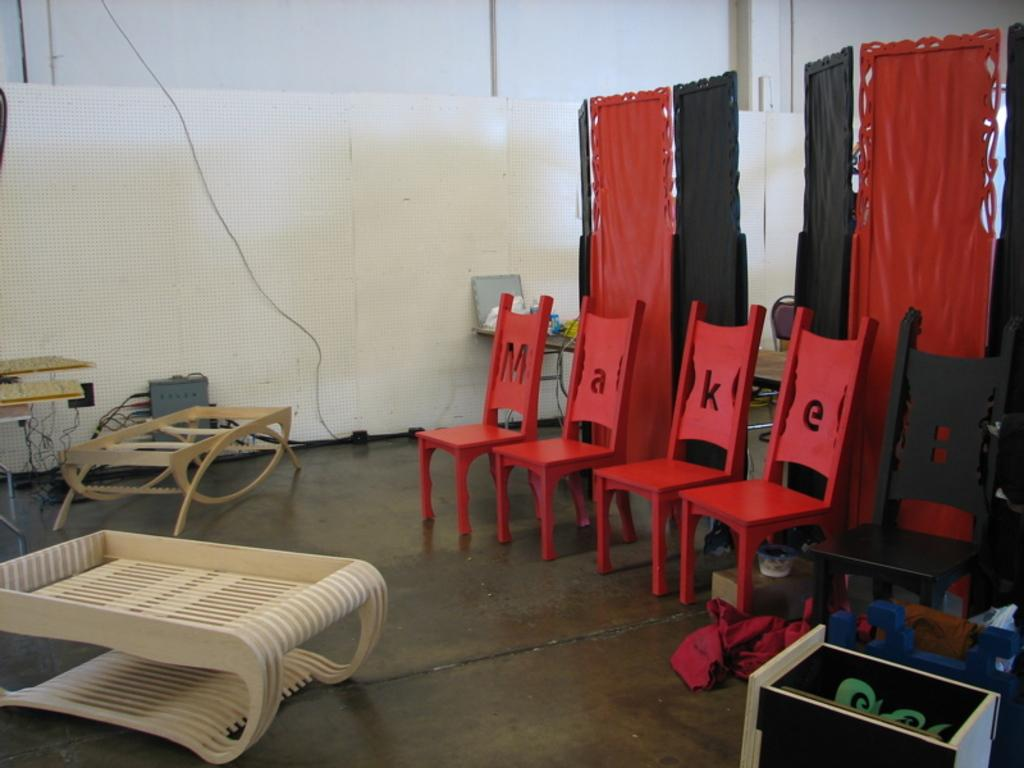What type of furniture is present in the image? There are chairs and tables in the image. What is on top of the tables in the image? There are objects on a table in the image. What kind of items can be seen in the image that require electricity? There are electronic objects in the image. Are there any visible connections between the electronic objects in the image? Yes, there are wires in the image. What type of surface can be seen in the image that is used for writing or displaying information? There are boards in the image. What type of structure can be seen in the background of the image? There is a wall in the image. Can you describe the harmony between the branches and the sense of the image? There are no branches or senses mentioned in the image; it features chairs, tables, electronic objects, wires, boards, and a wall. 